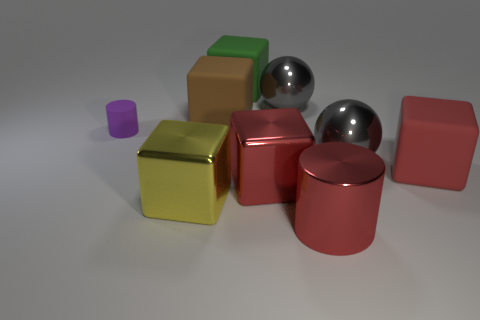Subtract all big red metallic blocks. How many blocks are left? 4 Subtract all green blocks. How many blocks are left? 4 Subtract all blue cubes. Subtract all brown cylinders. How many cubes are left? 5 Subtract all spheres. How many objects are left? 7 Add 8 red matte things. How many red matte things are left? 9 Add 3 purple blocks. How many purple blocks exist? 3 Subtract 1 red cubes. How many objects are left? 8 Subtract all large yellow shiny things. Subtract all matte things. How many objects are left? 4 